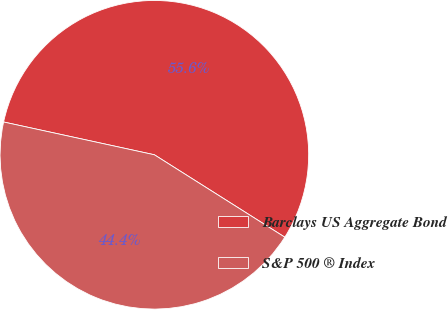<chart> <loc_0><loc_0><loc_500><loc_500><pie_chart><fcel>Barclays US Aggregate Bond<fcel>S&P 500 ® Index<nl><fcel>55.56%<fcel>44.44%<nl></chart> 